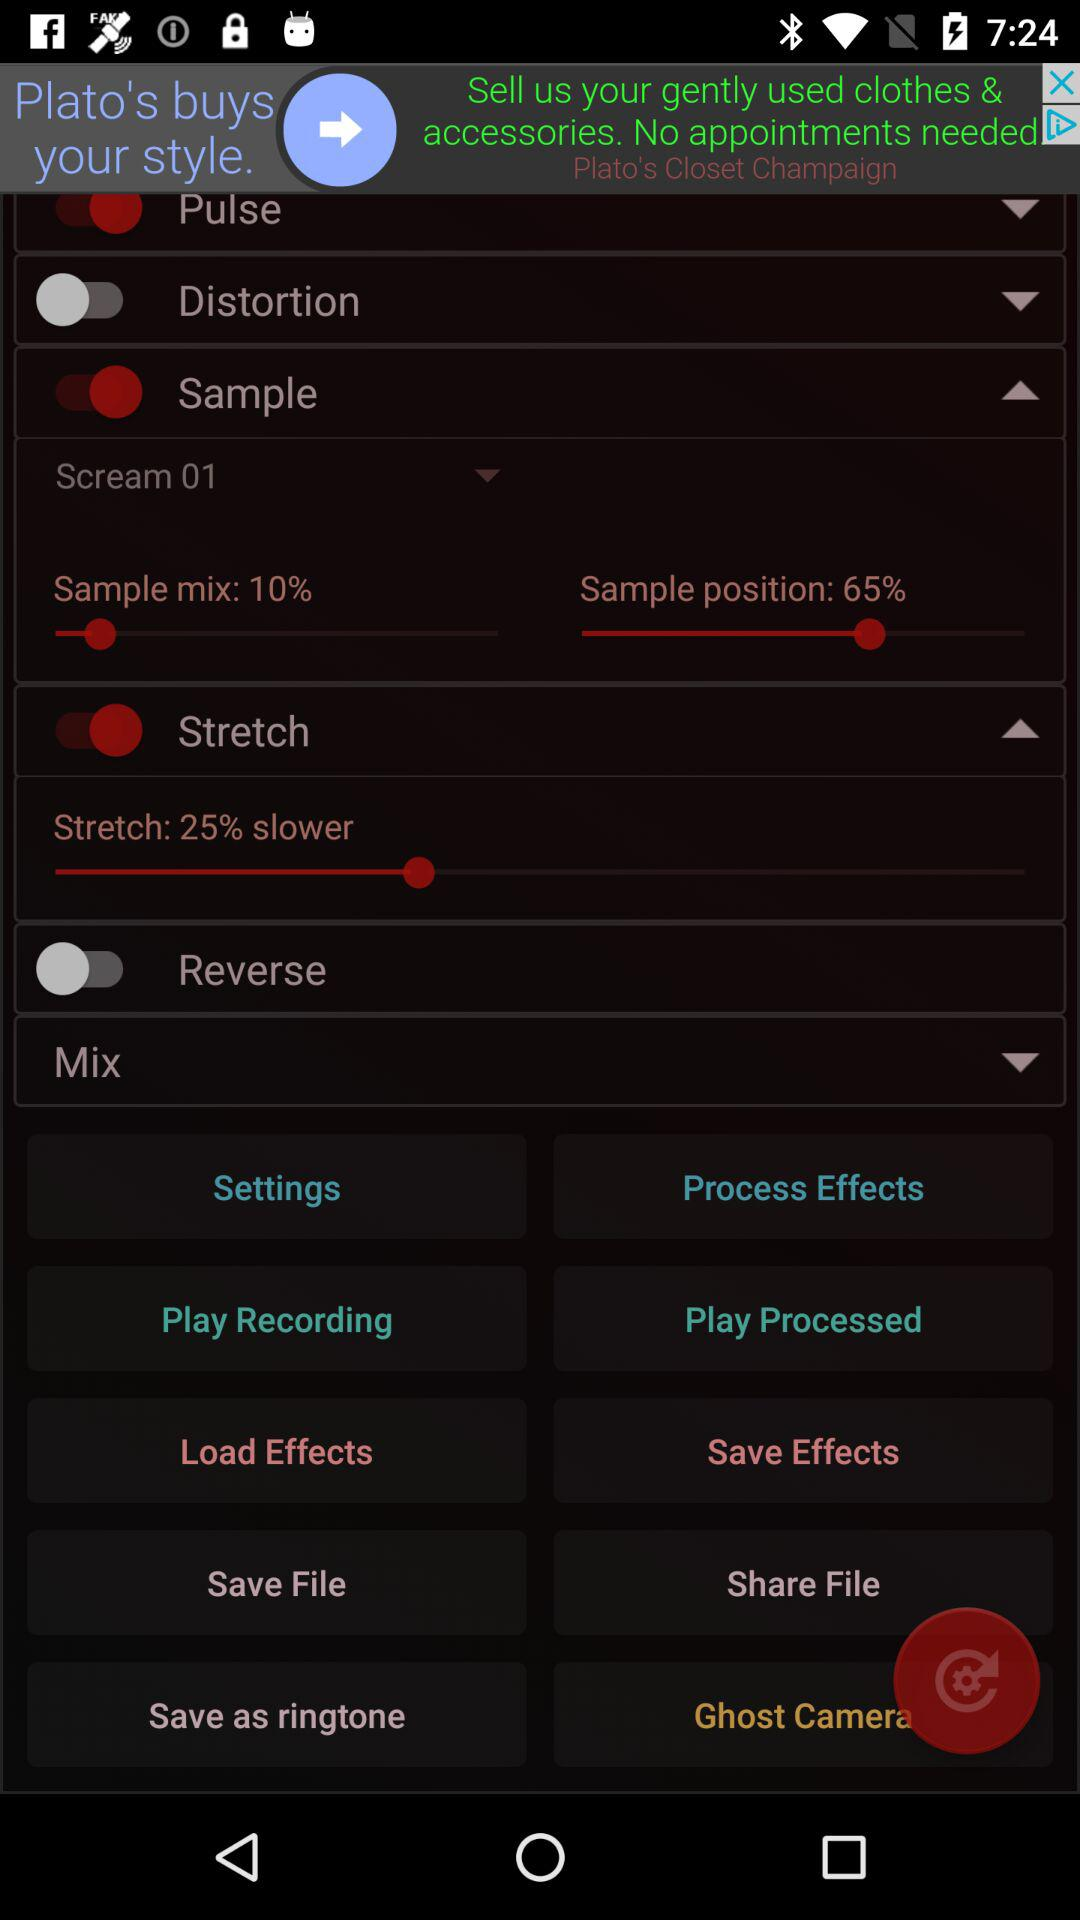What is the percentage of stretch? The percentage of stretch is 25% slower. 